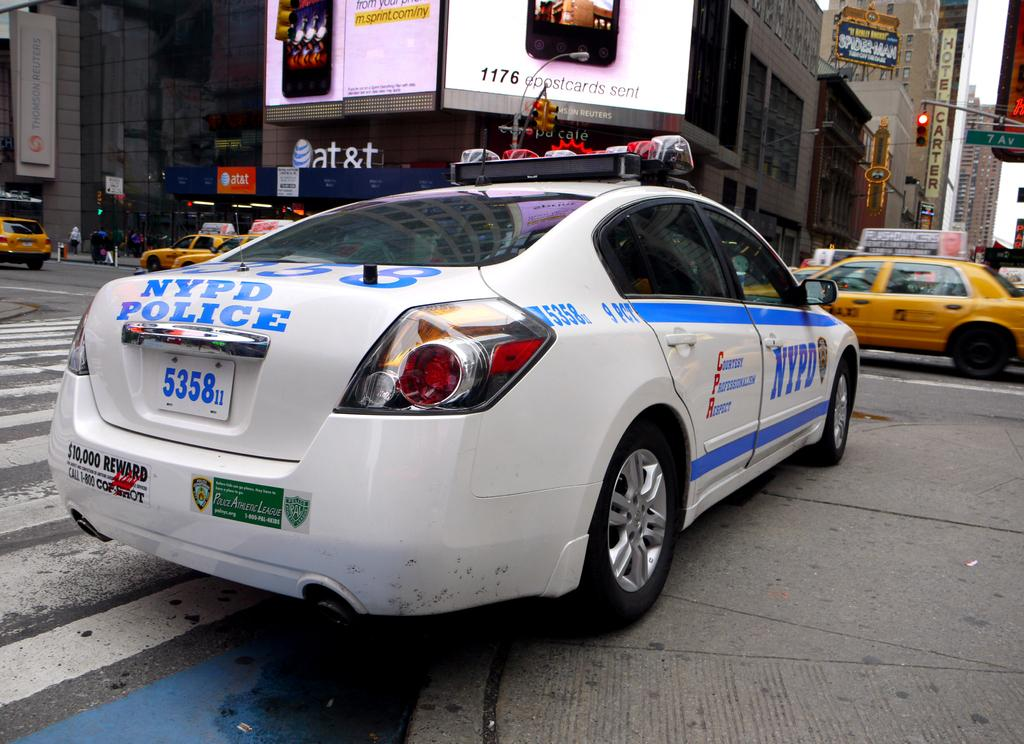What can be seen on the road in the image? There are cars on the road in the image. What else is visible in the image besides the cars? There are buildings visible in the image. Can you describe any additional features of the buildings? Advertisement banners are present on some of the buildings. How many geese are sitting on the hot drain in the image? There are no geese or drains present in the image. 